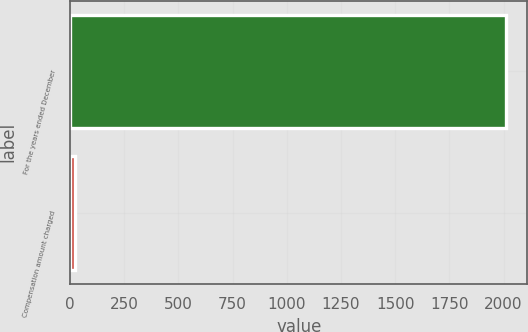<chart> <loc_0><loc_0><loc_500><loc_500><bar_chart><fcel>For the years ended December<fcel>Compensation amount charged<nl><fcel>2010<fcel>20.3<nl></chart> 